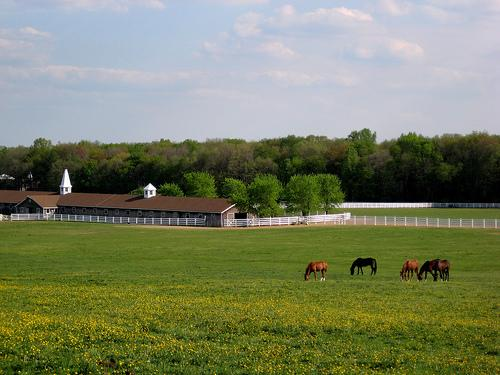In one sentence, describe the interaction between the horses and the grass. The horses are grazing on grass and interacting with the green field which also has yellow flowers in it. Describe the stable and its location in relation to the other objects in the image. The stable is brown and white, located near the grassy field, trees, and the white fence. Count the number of horses in the image and state the color of one of them. There are five horses; one of them has white on the lower part of its legs. Mention two attributes of the sky in the image. The sky has puffy clouds and is grayish blue in color. What is the overall mood or sentiment of the image? The image portrays a peaceful and tranquil mood, with horses grazing on grass in a beautiful countryside setting. In a short sentence, describe the overall setting of the picture. The image shows a grassy field with horses, a white fence, a stable, and trees with a cloudy sky above. What is the color and description of the fence in the image? The fence is white in color and is made of wood. List three animals and actions happening in the image. Five horses are grazing, a light brown horse is on the grass, and a black horse is on the grass. What type of flowers can be seen in the grass? Yellow flowers are present in the grass. Give two details about the trees in the image. The trees have bright green leaves and are located in a row behind the stable. Do the trees have no leaves or sparse foliage? The image has captions that mention "the tree has bright green leaves on it," "a row of green trees," "dense foliage behind the fence," and "the large area of trees in the back," all indicating that the trees have leaves and dense foliage, not sparse or no leaves. Are there red flowers in the grassy field? The image mentions "the grass has yellow flowers in it," "yellow flowers in the field," and "the yellow flowers in the field" which all suggest that there are yellow flowers in the field, not red flowers. Are there no tall structures on the brown and white stable? There is a caption that mentions "the steeple on the house is white" and "tall white narrow tower," which indicate the presence of a tall structure on the stable. Is the fence of a different color than white? There are several captions mentioning a white fence - "the fence is white in color," "a white wooden fence," "the white fence," and "white fence surrounding the field," which all point to the fence being white in color. Are there only three horses grazing on the grass? There are captions mentioning "the five horses are grazing," "a light brown horse on the grass," "a black horse on the grass," and "a dark brown horse on the grass," which indicate at least five horses grazing on the grass, not just three. Is the sky completely clear without any clouds? The image mentions both "a cloudy blue sky" and "the sky has puffy clouds in it" as well as "the clouds are grayish blue" which indicate the presence of clouds in the sky, and not a clear sky. 